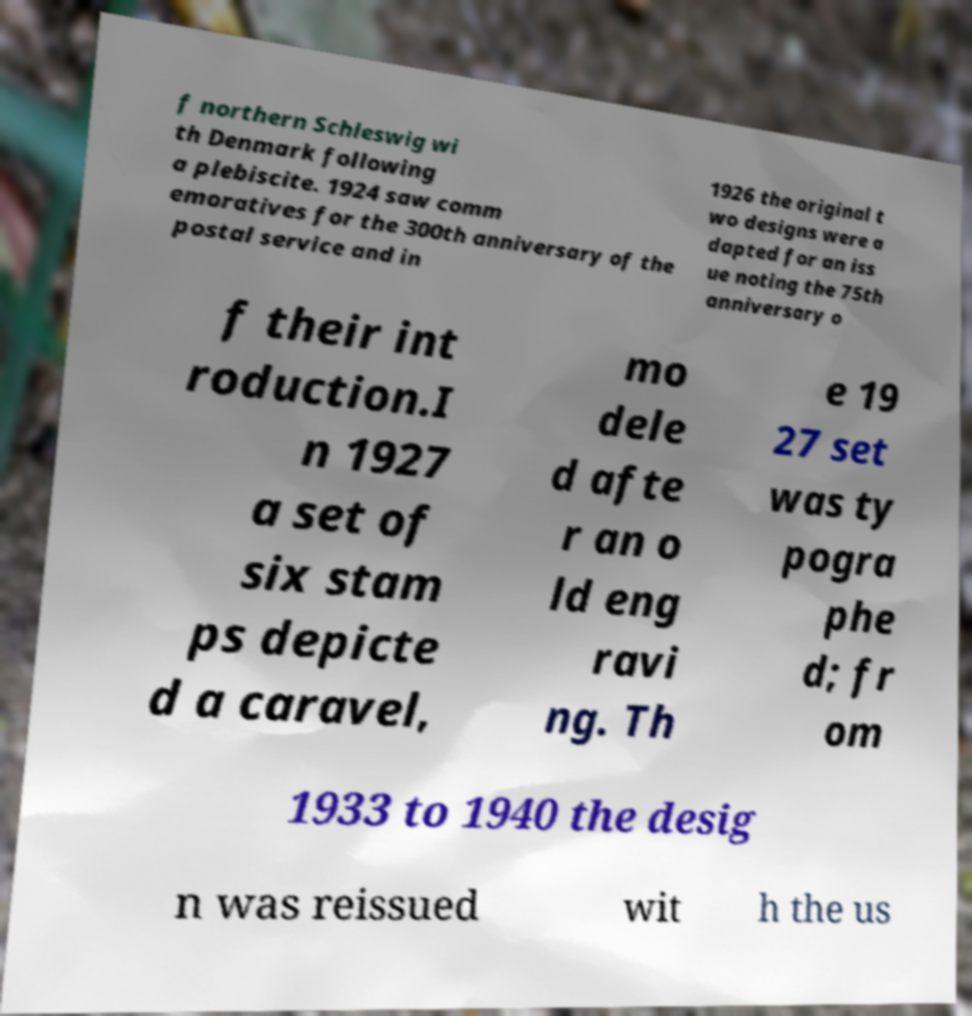There's text embedded in this image that I need extracted. Can you transcribe it verbatim? f northern Schleswig wi th Denmark following a plebiscite. 1924 saw comm emoratives for the 300th anniversary of the postal service and in 1926 the original t wo designs were a dapted for an iss ue noting the 75th anniversary o f their int roduction.I n 1927 a set of six stam ps depicte d a caravel, mo dele d afte r an o ld eng ravi ng. Th e 19 27 set was ty pogra phe d; fr om 1933 to 1940 the desig n was reissued wit h the us 